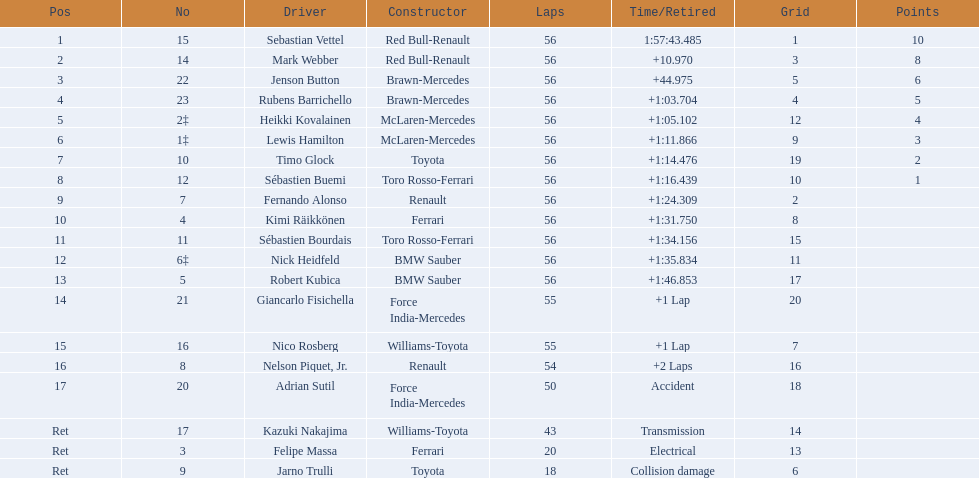Who were all of the drivers in the 2009 chinese grand prix? Sebastian Vettel, Mark Webber, Jenson Button, Rubens Barrichello, Heikki Kovalainen, Lewis Hamilton, Timo Glock, Sébastien Buemi, Fernando Alonso, Kimi Räikkönen, Sébastien Bourdais, Nick Heidfeld, Robert Kubica, Giancarlo Fisichella, Nico Rosberg, Nelson Piquet, Jr., Adrian Sutil, Kazuki Nakajima, Felipe Massa, Jarno Trulli. And what were their finishing times? 1:57:43.485, +10.970, +44.975, +1:03.704, +1:05.102, +1:11.866, +1:14.476, +1:16.439, +1:24.309, +1:31.750, +1:34.156, +1:35.834, +1:46.853, +1 Lap, +1 Lap, +2 Laps, Accident, Transmission, Electrical, Collision damage. Which player faced collision damage and retired from the race? Jarno Trulli. 